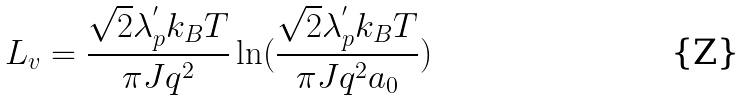<formula> <loc_0><loc_0><loc_500><loc_500>L _ { v } = \frac { \sqrt { 2 } \lambda ^ { ^ { \prime } } _ { p } k _ { B } T } { \pi J q ^ { 2 } } \ln ( \frac { \sqrt { 2 } \lambda ^ { ^ { \prime } } _ { p } k _ { B } T } { \pi J q ^ { 2 } a _ { 0 } } )</formula> 